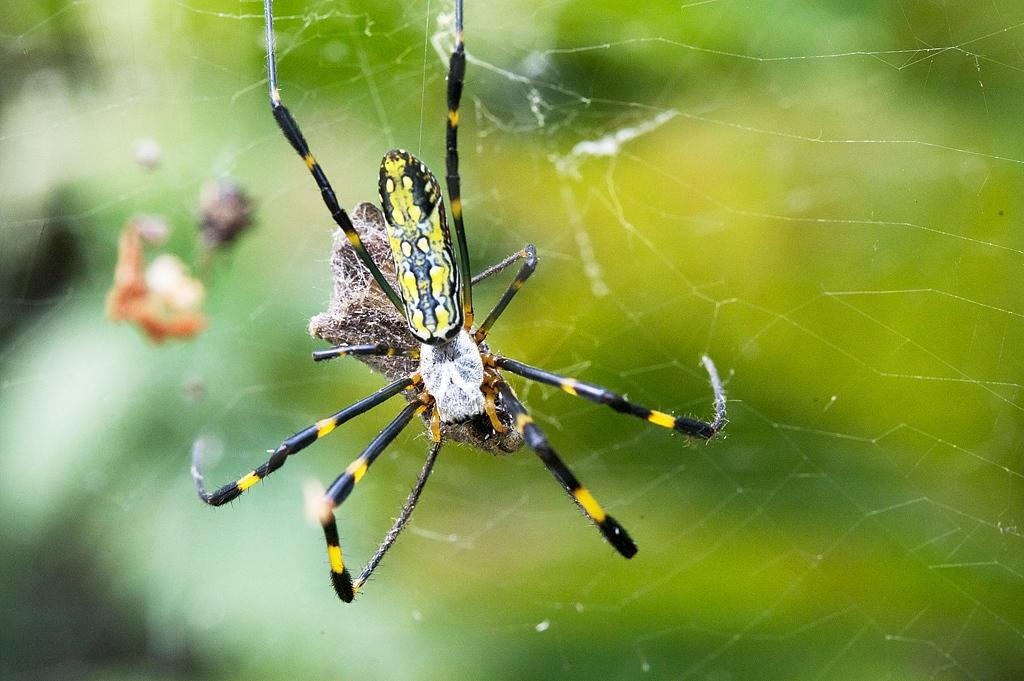What is the main subject of the image? There is a spider in the image. What is associated with the spider in the image? There is a spider web in the image. Can you describe the background of the image? The background of the image is blurred. What type of corn can be seen growing in the spider web in the image? There is no corn present in the image, and the spider web is not a place where corn would grow. 